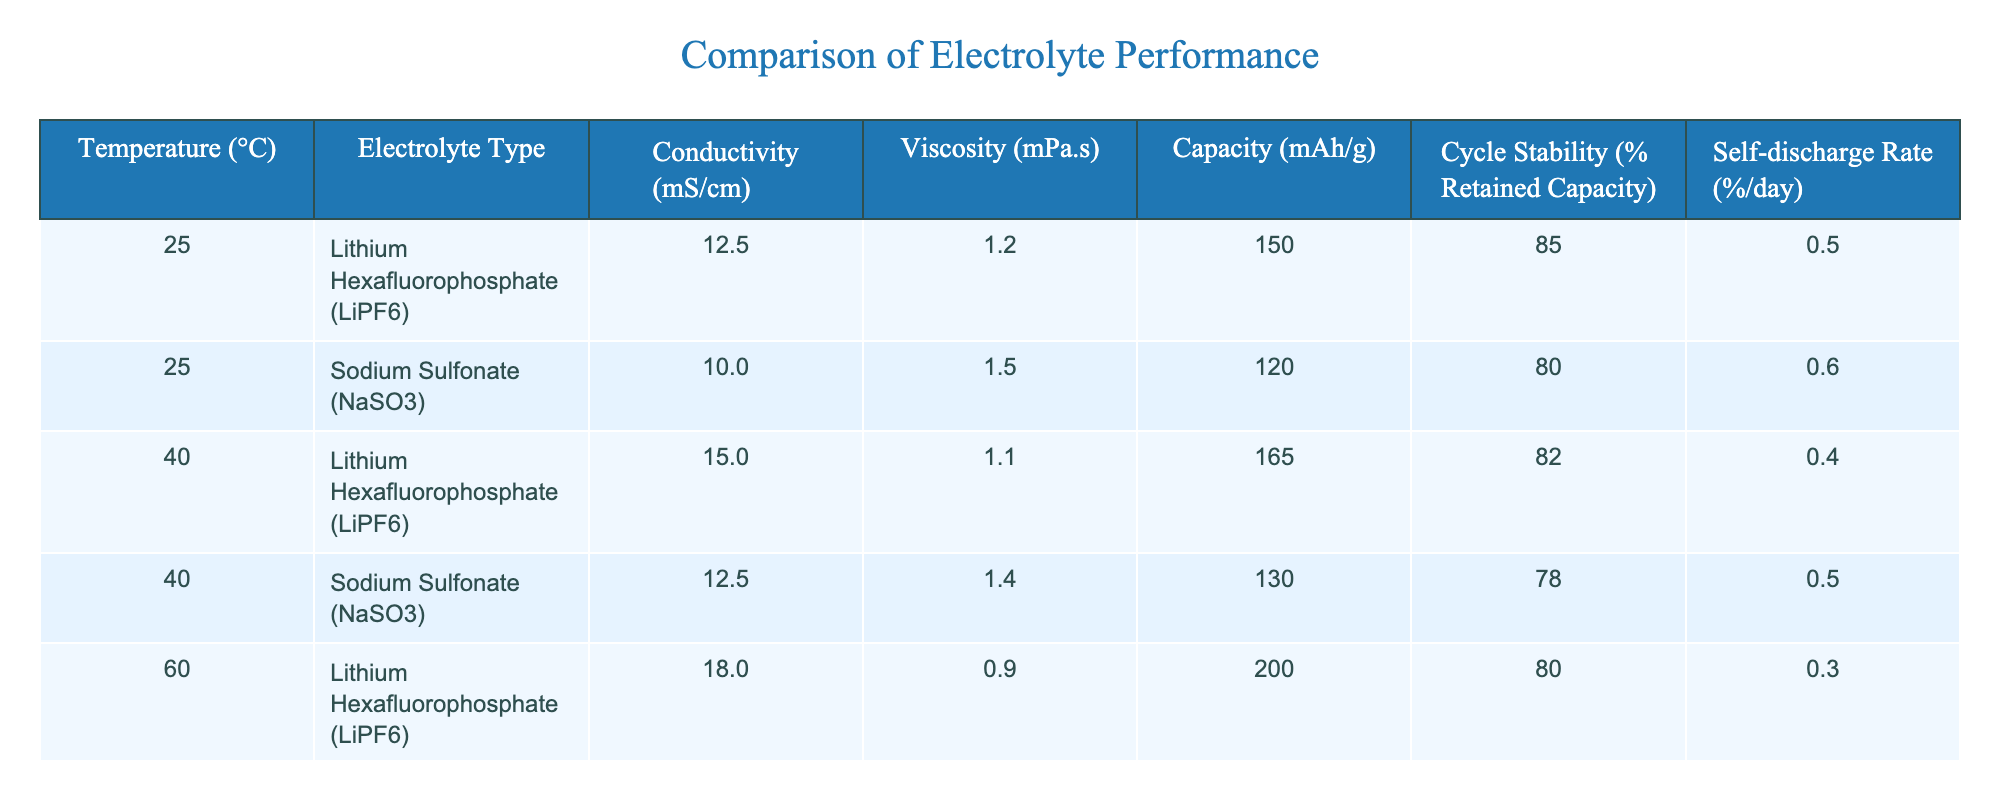What is the conductivity of Lithium Hexafluorophosphate at 60°C? According to the table, under the condition of 60°C, the conductivity for Lithium Hexafluorophosphate is listed as 18.0 mS/cm.
Answer: 18.0 mS/cm What is the self-discharge rate of Sodium Sulfonate at 25°C? The table indicates that the self-discharge rate for Sodium Sulfonate at a temperature of 25°C is 0.6% per day.
Answer: 0.6% per day At which temperature does Sodium Sulfonate have the highest cycle stability? Comparing the cycle stability of Sodium Sulfonate across different temperatures, at 25°C it has 80%, at 40°C it drops to 78%, at 60°C it is at 75%, and at 80°C it is 70%. Therefore, the highest cycle stability for Sodium Sulfonate is at 25°C, which is 80%.
Answer: 25°C What is the average capacity of Lithium Hexafluorophosphate across all temperature conditions? The capacities for Lithium Hexafluorophosphate at the various temperatures are 150, 165, 200, and 220 mAh/g. We sum these values: 150 + 165 + 200 + 220 = 735. To find the average, divide by the number of entries (4): 735 / 4 = 183.75 mAh/g.
Answer: 183.75 mAh/g Is the viscosity of Sodium Sulfonate lower at 40°C than at 25°C? The viscosity for Sodium Sulfonate at 25°C is 1.5 mPa.s and at 40°C it is 1.4 mPa.s. Since 1.4 is less than 1.5, we can confirm that the viscosity of Sodium Sulfonate is indeed lower at 40°C.
Answer: Yes Which electrolyte type shows a greater increase in conductivity from 25°C to 80°C? For Lithium Hexafluorophosphate, the increase in conductivity from 25°C (12.5 mS/cm) to 80°C (20.5 mS/cm) is 20.5 - 12.5 = 8.0 mS/cm. For Sodium Sulfonate, the increase from 25°C (10.0 mS/cm) to 80°C (17.5 mS/cm) is 17.5 - 10.0 = 7.5 mS/cm. Therefore, Lithium Hexafluorophosphate shows a greater increase in conductivity.
Answer: Lithium Hexafluorophosphate What is the ratio of cycle stability of Lithium Hexafluorophosphate at 25°C to that at 40°C? The cycle stability of Lithium Hexafluorophosphate at 25°C is 85% and at 40°C is 82%. The ratio can be calculated as 85 / 82, which simplifies approximately to 1.037.
Answer: 1.037 At 60°C, which electrolyte has a higher viscosity, and what is the value? At 60°C, Lithium Hexafluorophosphate has a viscosity of 0.9 mPa.s, while Sodium Sulfonate has a viscosity of 1.3 mPa.s. Since 1.3 is greater than 0.9, Sodium Sulfonate has a higher viscosity at this temperature.
Answer: Sodium Sulfonate, 1.3 mPa.s What is the difference in retained capacity between the two electrolytes at 80°C? For Lithium Hexafluorophosphate at 80°C, the retained capacity is 75% and for Sodium Sulfonate it is 70%. The difference can be calculated as 75% - 70% = 5%.
Answer: 5% 